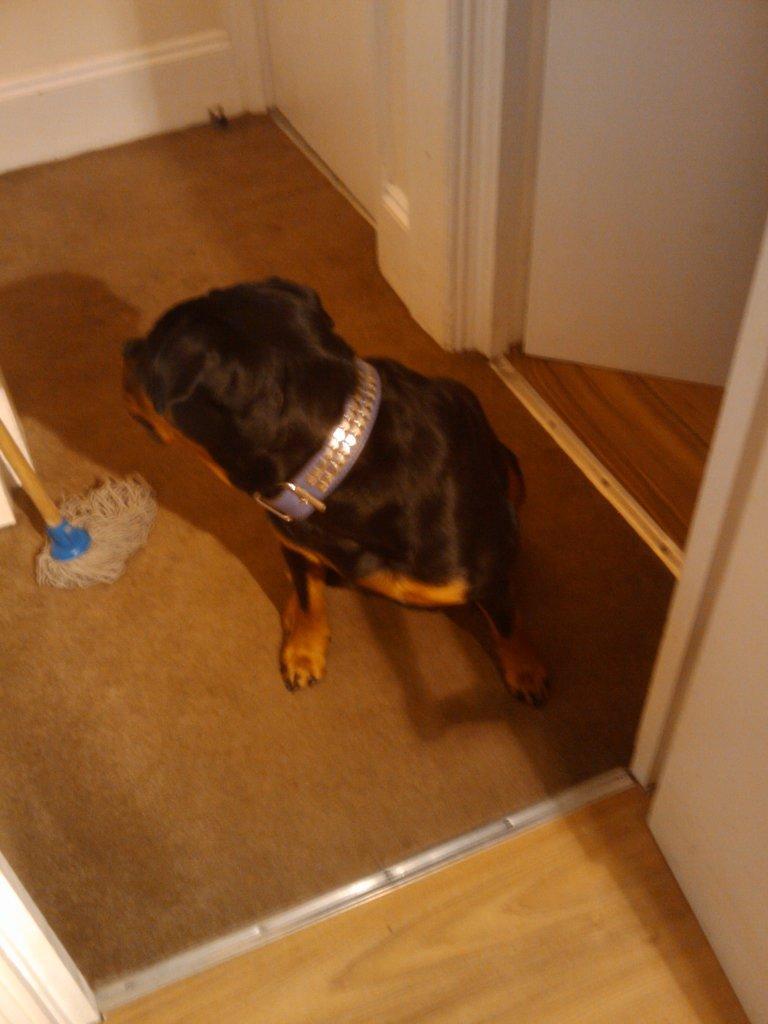Could you give a brief overview of what you see in this image? In this picture we can see a dog, mop stick on the floor, walls and some objects. 